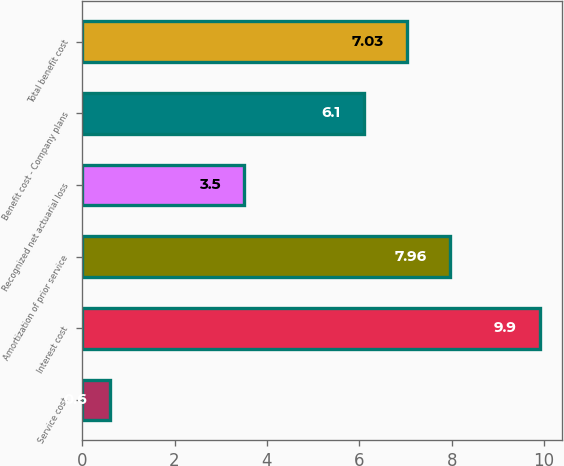<chart> <loc_0><loc_0><loc_500><loc_500><bar_chart><fcel>Service cost<fcel>Interest cost<fcel>Amortization of prior service<fcel>Recognized net actuarial loss<fcel>Benefit cost - Company plans<fcel>Total benefit cost<nl><fcel>0.6<fcel>9.9<fcel>7.96<fcel>3.5<fcel>6.1<fcel>7.03<nl></chart> 